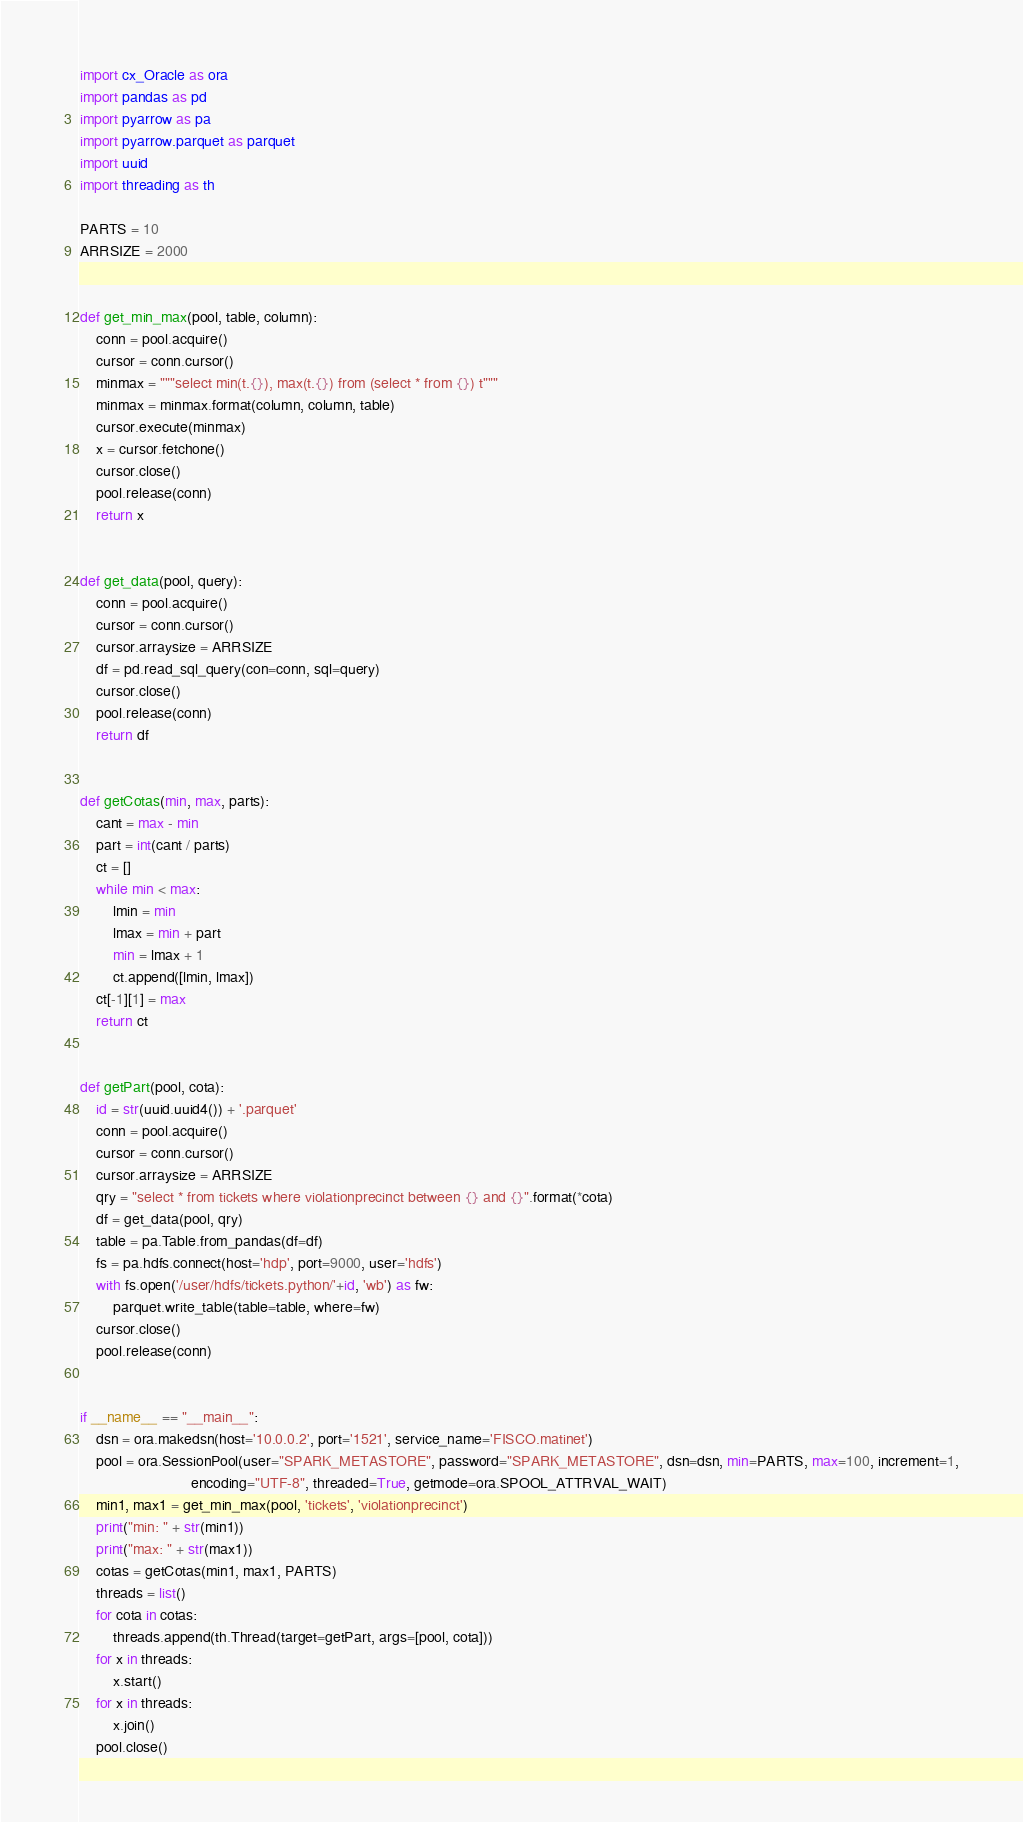<code> <loc_0><loc_0><loc_500><loc_500><_Python_>import cx_Oracle as ora
import pandas as pd
import pyarrow as pa
import pyarrow.parquet as parquet
import uuid
import threading as th

PARTS = 10
ARRSIZE = 2000


def get_min_max(pool, table, column):
    conn = pool.acquire()
    cursor = conn.cursor()
    minmax = """select min(t.{}), max(t.{}) from (select * from {}) t"""
    minmax = minmax.format(column, column, table)
    cursor.execute(minmax)
    x = cursor.fetchone()
    cursor.close()
    pool.release(conn)
    return x


def get_data(pool, query):
    conn = pool.acquire()
    cursor = conn.cursor()
    cursor.arraysize = ARRSIZE
    df = pd.read_sql_query(con=conn, sql=query)
    cursor.close()
    pool.release(conn)
    return df


def getCotas(min, max, parts):
    cant = max - min
    part = int(cant / parts)
    ct = []
    while min < max:
        lmin = min
        lmax = min + part
        min = lmax + 1
        ct.append([lmin, lmax])
    ct[-1][1] = max
    return ct


def getPart(pool, cota):
    id = str(uuid.uuid4()) + '.parquet'
    conn = pool.acquire()
    cursor = conn.cursor()
    cursor.arraysize = ARRSIZE
    qry = "select * from tickets where violationprecinct between {} and {}".format(*cota)
    df = get_data(pool, qry)
    table = pa.Table.from_pandas(df=df)
    fs = pa.hdfs.connect(host='hdp', port=9000, user='hdfs')
    with fs.open('/user/hdfs/tickets.python/'+id, 'wb') as fw:
        parquet.write_table(table=table, where=fw)
    cursor.close()
    pool.release(conn)


if __name__ == "__main__":
    dsn = ora.makedsn(host='10.0.0.2', port='1521', service_name='FISCO.matinet')
    pool = ora.SessionPool(user="SPARK_METASTORE", password="SPARK_METASTORE", dsn=dsn, min=PARTS, max=100, increment=1,
                           encoding="UTF-8", threaded=True, getmode=ora.SPOOL_ATTRVAL_WAIT)
    min1, max1 = get_min_max(pool, 'tickets', 'violationprecinct')
    print("min: " + str(min1))
    print("max: " + str(max1))
    cotas = getCotas(min1, max1, PARTS)
    threads = list()
    for cota in cotas:
        threads.append(th.Thread(target=getPart, args=[pool, cota]))
    for x in threads:
        x.start()
    for x in threads:
        x.join()
    pool.close()
</code> 